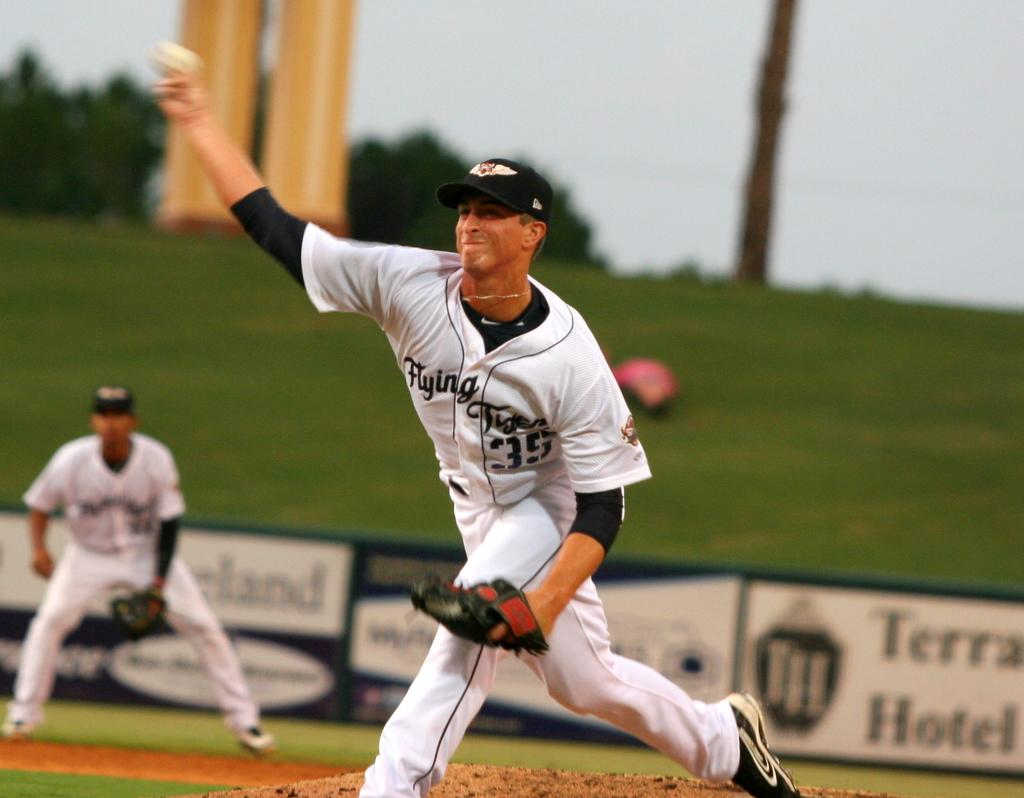<image>
Provide a brief description of the given image. Baseball player wearing number 35 pitching the ball. 